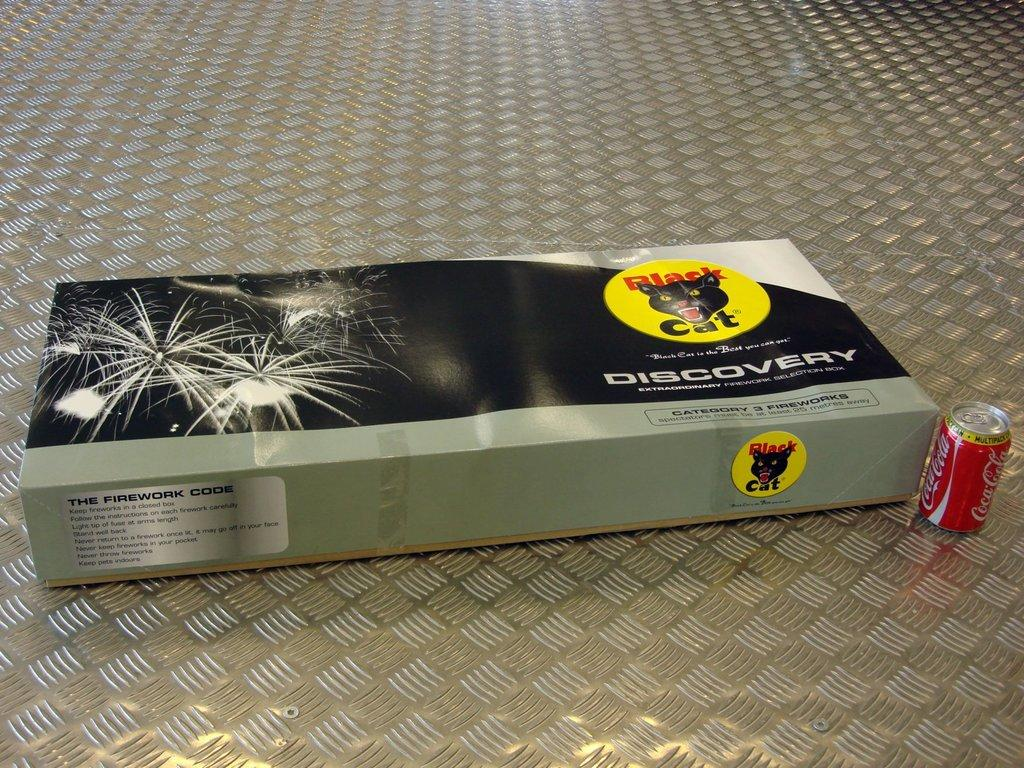Provide a one-sentence caption for the provided image. A box of black cat fireworks called discovery. 